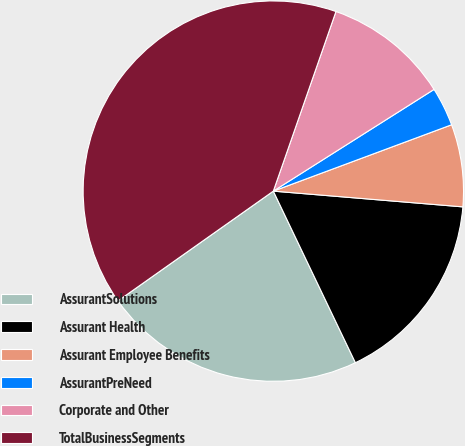Convert chart to OTSL. <chart><loc_0><loc_0><loc_500><loc_500><pie_chart><fcel>AssurantSolutions<fcel>Assurant Health<fcel>Assurant Employee Benefits<fcel>AssurantPreNeed<fcel>Corporate and Other<fcel>TotalBusinessSegments<nl><fcel>22.31%<fcel>16.58%<fcel>6.99%<fcel>3.31%<fcel>10.68%<fcel>40.13%<nl></chart> 